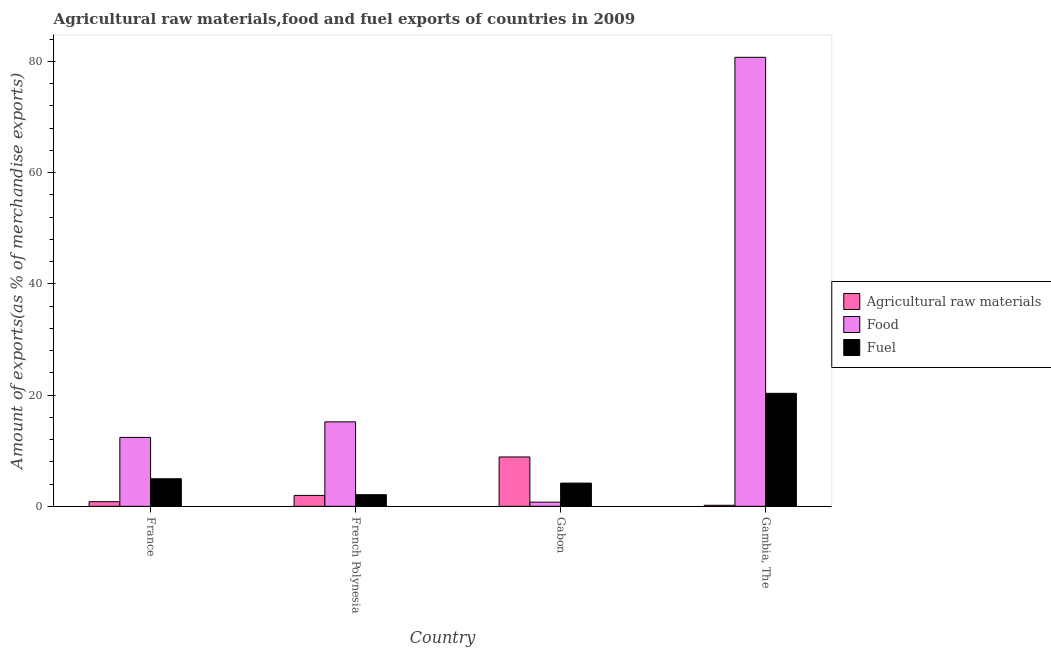How many bars are there on the 1st tick from the left?
Your answer should be compact. 3. What is the label of the 4th group of bars from the left?
Keep it short and to the point. Gambia, The. What is the percentage of raw materials exports in Gambia, The?
Provide a short and direct response. 0.19. Across all countries, what is the maximum percentage of food exports?
Offer a very short reply. 80.74. Across all countries, what is the minimum percentage of fuel exports?
Your answer should be very brief. 2.1. In which country was the percentage of fuel exports maximum?
Offer a very short reply. Gambia, The. In which country was the percentage of food exports minimum?
Offer a terse response. Gabon. What is the total percentage of fuel exports in the graph?
Offer a terse response. 31.57. What is the difference between the percentage of fuel exports in France and that in Gambia, The?
Offer a terse response. -15.36. What is the difference between the percentage of fuel exports in French Polynesia and the percentage of food exports in Gambia, The?
Provide a short and direct response. -78.65. What is the average percentage of fuel exports per country?
Give a very brief answer. 7.89. What is the difference between the percentage of food exports and percentage of fuel exports in France?
Your answer should be very brief. 7.44. What is the ratio of the percentage of fuel exports in French Polynesia to that in Gambia, The?
Make the answer very short. 0.1. Is the difference between the percentage of fuel exports in Gabon and Gambia, The greater than the difference between the percentage of food exports in Gabon and Gambia, The?
Your response must be concise. Yes. What is the difference between the highest and the second highest percentage of raw materials exports?
Provide a short and direct response. 6.91. What is the difference between the highest and the lowest percentage of raw materials exports?
Offer a terse response. 8.69. In how many countries, is the percentage of food exports greater than the average percentage of food exports taken over all countries?
Provide a short and direct response. 1. What does the 2nd bar from the left in France represents?
Ensure brevity in your answer.  Food. What does the 3rd bar from the right in Gabon represents?
Ensure brevity in your answer.  Agricultural raw materials. Is it the case that in every country, the sum of the percentage of raw materials exports and percentage of food exports is greater than the percentage of fuel exports?
Offer a very short reply. Yes. How many bars are there?
Offer a terse response. 12. Are all the bars in the graph horizontal?
Provide a succinct answer. No. How many countries are there in the graph?
Provide a succinct answer. 4. Are the values on the major ticks of Y-axis written in scientific E-notation?
Offer a terse response. No. Where does the legend appear in the graph?
Provide a short and direct response. Center right. How many legend labels are there?
Provide a short and direct response. 3. How are the legend labels stacked?
Keep it short and to the point. Vertical. What is the title of the graph?
Offer a very short reply. Agricultural raw materials,food and fuel exports of countries in 2009. What is the label or title of the X-axis?
Keep it short and to the point. Country. What is the label or title of the Y-axis?
Your answer should be compact. Amount of exports(as % of merchandise exports). What is the Amount of exports(as % of merchandise exports) in Agricultural raw materials in France?
Give a very brief answer. 0.84. What is the Amount of exports(as % of merchandise exports) of Food in France?
Offer a very short reply. 12.4. What is the Amount of exports(as % of merchandise exports) in Fuel in France?
Offer a terse response. 4.96. What is the Amount of exports(as % of merchandise exports) of Agricultural raw materials in French Polynesia?
Make the answer very short. 1.97. What is the Amount of exports(as % of merchandise exports) of Food in French Polynesia?
Make the answer very short. 15.19. What is the Amount of exports(as % of merchandise exports) of Fuel in French Polynesia?
Ensure brevity in your answer.  2.1. What is the Amount of exports(as % of merchandise exports) of Agricultural raw materials in Gabon?
Offer a very short reply. 8.88. What is the Amount of exports(as % of merchandise exports) of Food in Gabon?
Your answer should be very brief. 0.76. What is the Amount of exports(as % of merchandise exports) in Fuel in Gabon?
Provide a short and direct response. 4.18. What is the Amount of exports(as % of merchandise exports) of Agricultural raw materials in Gambia, The?
Offer a terse response. 0.19. What is the Amount of exports(as % of merchandise exports) in Food in Gambia, The?
Offer a very short reply. 80.74. What is the Amount of exports(as % of merchandise exports) in Fuel in Gambia, The?
Keep it short and to the point. 20.32. Across all countries, what is the maximum Amount of exports(as % of merchandise exports) in Agricultural raw materials?
Make the answer very short. 8.88. Across all countries, what is the maximum Amount of exports(as % of merchandise exports) in Food?
Provide a short and direct response. 80.74. Across all countries, what is the maximum Amount of exports(as % of merchandise exports) of Fuel?
Your response must be concise. 20.32. Across all countries, what is the minimum Amount of exports(as % of merchandise exports) of Agricultural raw materials?
Keep it short and to the point. 0.19. Across all countries, what is the minimum Amount of exports(as % of merchandise exports) in Food?
Provide a short and direct response. 0.76. Across all countries, what is the minimum Amount of exports(as % of merchandise exports) of Fuel?
Make the answer very short. 2.1. What is the total Amount of exports(as % of merchandise exports) of Agricultural raw materials in the graph?
Offer a terse response. 11.88. What is the total Amount of exports(as % of merchandise exports) in Food in the graph?
Offer a terse response. 109.09. What is the total Amount of exports(as % of merchandise exports) of Fuel in the graph?
Make the answer very short. 31.57. What is the difference between the Amount of exports(as % of merchandise exports) of Agricultural raw materials in France and that in French Polynesia?
Your response must be concise. -1.13. What is the difference between the Amount of exports(as % of merchandise exports) of Food in France and that in French Polynesia?
Offer a very short reply. -2.8. What is the difference between the Amount of exports(as % of merchandise exports) in Fuel in France and that in French Polynesia?
Ensure brevity in your answer.  2.86. What is the difference between the Amount of exports(as % of merchandise exports) of Agricultural raw materials in France and that in Gabon?
Offer a very short reply. -8.04. What is the difference between the Amount of exports(as % of merchandise exports) of Food in France and that in Gabon?
Offer a terse response. 11.64. What is the difference between the Amount of exports(as % of merchandise exports) of Fuel in France and that in Gabon?
Provide a succinct answer. 0.78. What is the difference between the Amount of exports(as % of merchandise exports) in Agricultural raw materials in France and that in Gambia, The?
Give a very brief answer. 0.65. What is the difference between the Amount of exports(as % of merchandise exports) of Food in France and that in Gambia, The?
Your answer should be very brief. -68.35. What is the difference between the Amount of exports(as % of merchandise exports) in Fuel in France and that in Gambia, The?
Offer a very short reply. -15.36. What is the difference between the Amount of exports(as % of merchandise exports) of Agricultural raw materials in French Polynesia and that in Gabon?
Provide a succinct answer. -6.91. What is the difference between the Amount of exports(as % of merchandise exports) in Food in French Polynesia and that in Gabon?
Ensure brevity in your answer.  14.44. What is the difference between the Amount of exports(as % of merchandise exports) of Fuel in French Polynesia and that in Gabon?
Give a very brief answer. -2.09. What is the difference between the Amount of exports(as % of merchandise exports) of Agricultural raw materials in French Polynesia and that in Gambia, The?
Provide a short and direct response. 1.77. What is the difference between the Amount of exports(as % of merchandise exports) of Food in French Polynesia and that in Gambia, The?
Your answer should be very brief. -65.55. What is the difference between the Amount of exports(as % of merchandise exports) in Fuel in French Polynesia and that in Gambia, The?
Provide a short and direct response. -18.23. What is the difference between the Amount of exports(as % of merchandise exports) in Agricultural raw materials in Gabon and that in Gambia, The?
Your answer should be very brief. 8.69. What is the difference between the Amount of exports(as % of merchandise exports) of Food in Gabon and that in Gambia, The?
Provide a succinct answer. -79.99. What is the difference between the Amount of exports(as % of merchandise exports) of Fuel in Gabon and that in Gambia, The?
Your response must be concise. -16.14. What is the difference between the Amount of exports(as % of merchandise exports) of Agricultural raw materials in France and the Amount of exports(as % of merchandise exports) of Food in French Polynesia?
Provide a short and direct response. -14.35. What is the difference between the Amount of exports(as % of merchandise exports) in Agricultural raw materials in France and the Amount of exports(as % of merchandise exports) in Fuel in French Polynesia?
Make the answer very short. -1.26. What is the difference between the Amount of exports(as % of merchandise exports) of Food in France and the Amount of exports(as % of merchandise exports) of Fuel in French Polynesia?
Offer a terse response. 10.3. What is the difference between the Amount of exports(as % of merchandise exports) in Agricultural raw materials in France and the Amount of exports(as % of merchandise exports) in Food in Gabon?
Provide a short and direct response. 0.08. What is the difference between the Amount of exports(as % of merchandise exports) of Agricultural raw materials in France and the Amount of exports(as % of merchandise exports) of Fuel in Gabon?
Your answer should be very brief. -3.34. What is the difference between the Amount of exports(as % of merchandise exports) in Food in France and the Amount of exports(as % of merchandise exports) in Fuel in Gabon?
Your answer should be very brief. 8.21. What is the difference between the Amount of exports(as % of merchandise exports) in Agricultural raw materials in France and the Amount of exports(as % of merchandise exports) in Food in Gambia, The?
Your response must be concise. -79.9. What is the difference between the Amount of exports(as % of merchandise exports) of Agricultural raw materials in France and the Amount of exports(as % of merchandise exports) of Fuel in Gambia, The?
Keep it short and to the point. -19.48. What is the difference between the Amount of exports(as % of merchandise exports) in Food in France and the Amount of exports(as % of merchandise exports) in Fuel in Gambia, The?
Your answer should be compact. -7.93. What is the difference between the Amount of exports(as % of merchandise exports) in Agricultural raw materials in French Polynesia and the Amount of exports(as % of merchandise exports) in Food in Gabon?
Your response must be concise. 1.21. What is the difference between the Amount of exports(as % of merchandise exports) of Agricultural raw materials in French Polynesia and the Amount of exports(as % of merchandise exports) of Fuel in Gabon?
Keep it short and to the point. -2.22. What is the difference between the Amount of exports(as % of merchandise exports) in Food in French Polynesia and the Amount of exports(as % of merchandise exports) in Fuel in Gabon?
Make the answer very short. 11.01. What is the difference between the Amount of exports(as % of merchandise exports) in Agricultural raw materials in French Polynesia and the Amount of exports(as % of merchandise exports) in Food in Gambia, The?
Keep it short and to the point. -78.78. What is the difference between the Amount of exports(as % of merchandise exports) of Agricultural raw materials in French Polynesia and the Amount of exports(as % of merchandise exports) of Fuel in Gambia, The?
Give a very brief answer. -18.36. What is the difference between the Amount of exports(as % of merchandise exports) of Food in French Polynesia and the Amount of exports(as % of merchandise exports) of Fuel in Gambia, The?
Provide a succinct answer. -5.13. What is the difference between the Amount of exports(as % of merchandise exports) in Agricultural raw materials in Gabon and the Amount of exports(as % of merchandise exports) in Food in Gambia, The?
Offer a very short reply. -71.86. What is the difference between the Amount of exports(as % of merchandise exports) in Agricultural raw materials in Gabon and the Amount of exports(as % of merchandise exports) in Fuel in Gambia, The?
Give a very brief answer. -11.44. What is the difference between the Amount of exports(as % of merchandise exports) of Food in Gabon and the Amount of exports(as % of merchandise exports) of Fuel in Gambia, The?
Provide a succinct answer. -19.57. What is the average Amount of exports(as % of merchandise exports) of Agricultural raw materials per country?
Your answer should be compact. 2.97. What is the average Amount of exports(as % of merchandise exports) of Food per country?
Your answer should be very brief. 27.27. What is the average Amount of exports(as % of merchandise exports) of Fuel per country?
Ensure brevity in your answer.  7.89. What is the difference between the Amount of exports(as % of merchandise exports) of Agricultural raw materials and Amount of exports(as % of merchandise exports) of Food in France?
Keep it short and to the point. -11.56. What is the difference between the Amount of exports(as % of merchandise exports) in Agricultural raw materials and Amount of exports(as % of merchandise exports) in Fuel in France?
Your answer should be very brief. -4.12. What is the difference between the Amount of exports(as % of merchandise exports) of Food and Amount of exports(as % of merchandise exports) of Fuel in France?
Your answer should be compact. 7.44. What is the difference between the Amount of exports(as % of merchandise exports) of Agricultural raw materials and Amount of exports(as % of merchandise exports) of Food in French Polynesia?
Your response must be concise. -13.23. What is the difference between the Amount of exports(as % of merchandise exports) of Agricultural raw materials and Amount of exports(as % of merchandise exports) of Fuel in French Polynesia?
Your response must be concise. -0.13. What is the difference between the Amount of exports(as % of merchandise exports) of Food and Amount of exports(as % of merchandise exports) of Fuel in French Polynesia?
Your response must be concise. 13.1. What is the difference between the Amount of exports(as % of merchandise exports) in Agricultural raw materials and Amount of exports(as % of merchandise exports) in Food in Gabon?
Offer a very short reply. 8.13. What is the difference between the Amount of exports(as % of merchandise exports) in Agricultural raw materials and Amount of exports(as % of merchandise exports) in Fuel in Gabon?
Keep it short and to the point. 4.7. What is the difference between the Amount of exports(as % of merchandise exports) in Food and Amount of exports(as % of merchandise exports) in Fuel in Gabon?
Provide a succinct answer. -3.43. What is the difference between the Amount of exports(as % of merchandise exports) of Agricultural raw materials and Amount of exports(as % of merchandise exports) of Food in Gambia, The?
Your answer should be compact. -80.55. What is the difference between the Amount of exports(as % of merchandise exports) of Agricultural raw materials and Amount of exports(as % of merchandise exports) of Fuel in Gambia, The?
Provide a short and direct response. -20.13. What is the difference between the Amount of exports(as % of merchandise exports) in Food and Amount of exports(as % of merchandise exports) in Fuel in Gambia, The?
Keep it short and to the point. 60.42. What is the ratio of the Amount of exports(as % of merchandise exports) of Agricultural raw materials in France to that in French Polynesia?
Ensure brevity in your answer.  0.43. What is the ratio of the Amount of exports(as % of merchandise exports) of Food in France to that in French Polynesia?
Offer a very short reply. 0.82. What is the ratio of the Amount of exports(as % of merchandise exports) in Fuel in France to that in French Polynesia?
Offer a terse response. 2.36. What is the ratio of the Amount of exports(as % of merchandise exports) of Agricultural raw materials in France to that in Gabon?
Make the answer very short. 0.09. What is the ratio of the Amount of exports(as % of merchandise exports) in Food in France to that in Gabon?
Offer a terse response. 16.4. What is the ratio of the Amount of exports(as % of merchandise exports) in Fuel in France to that in Gabon?
Ensure brevity in your answer.  1.19. What is the ratio of the Amount of exports(as % of merchandise exports) of Agricultural raw materials in France to that in Gambia, The?
Keep it short and to the point. 4.35. What is the ratio of the Amount of exports(as % of merchandise exports) in Food in France to that in Gambia, The?
Provide a short and direct response. 0.15. What is the ratio of the Amount of exports(as % of merchandise exports) in Fuel in France to that in Gambia, The?
Your response must be concise. 0.24. What is the ratio of the Amount of exports(as % of merchandise exports) in Agricultural raw materials in French Polynesia to that in Gabon?
Give a very brief answer. 0.22. What is the ratio of the Amount of exports(as % of merchandise exports) of Food in French Polynesia to that in Gabon?
Give a very brief answer. 20.11. What is the ratio of the Amount of exports(as % of merchandise exports) of Fuel in French Polynesia to that in Gabon?
Keep it short and to the point. 0.5. What is the ratio of the Amount of exports(as % of merchandise exports) of Agricultural raw materials in French Polynesia to that in Gambia, The?
Offer a very short reply. 10.18. What is the ratio of the Amount of exports(as % of merchandise exports) in Food in French Polynesia to that in Gambia, The?
Ensure brevity in your answer.  0.19. What is the ratio of the Amount of exports(as % of merchandise exports) in Fuel in French Polynesia to that in Gambia, The?
Your response must be concise. 0.1. What is the ratio of the Amount of exports(as % of merchandise exports) in Agricultural raw materials in Gabon to that in Gambia, The?
Offer a terse response. 45.96. What is the ratio of the Amount of exports(as % of merchandise exports) of Food in Gabon to that in Gambia, The?
Offer a terse response. 0.01. What is the ratio of the Amount of exports(as % of merchandise exports) in Fuel in Gabon to that in Gambia, The?
Offer a terse response. 0.21. What is the difference between the highest and the second highest Amount of exports(as % of merchandise exports) of Agricultural raw materials?
Offer a terse response. 6.91. What is the difference between the highest and the second highest Amount of exports(as % of merchandise exports) of Food?
Offer a very short reply. 65.55. What is the difference between the highest and the second highest Amount of exports(as % of merchandise exports) of Fuel?
Give a very brief answer. 15.36. What is the difference between the highest and the lowest Amount of exports(as % of merchandise exports) in Agricultural raw materials?
Give a very brief answer. 8.69. What is the difference between the highest and the lowest Amount of exports(as % of merchandise exports) in Food?
Make the answer very short. 79.99. What is the difference between the highest and the lowest Amount of exports(as % of merchandise exports) of Fuel?
Make the answer very short. 18.23. 